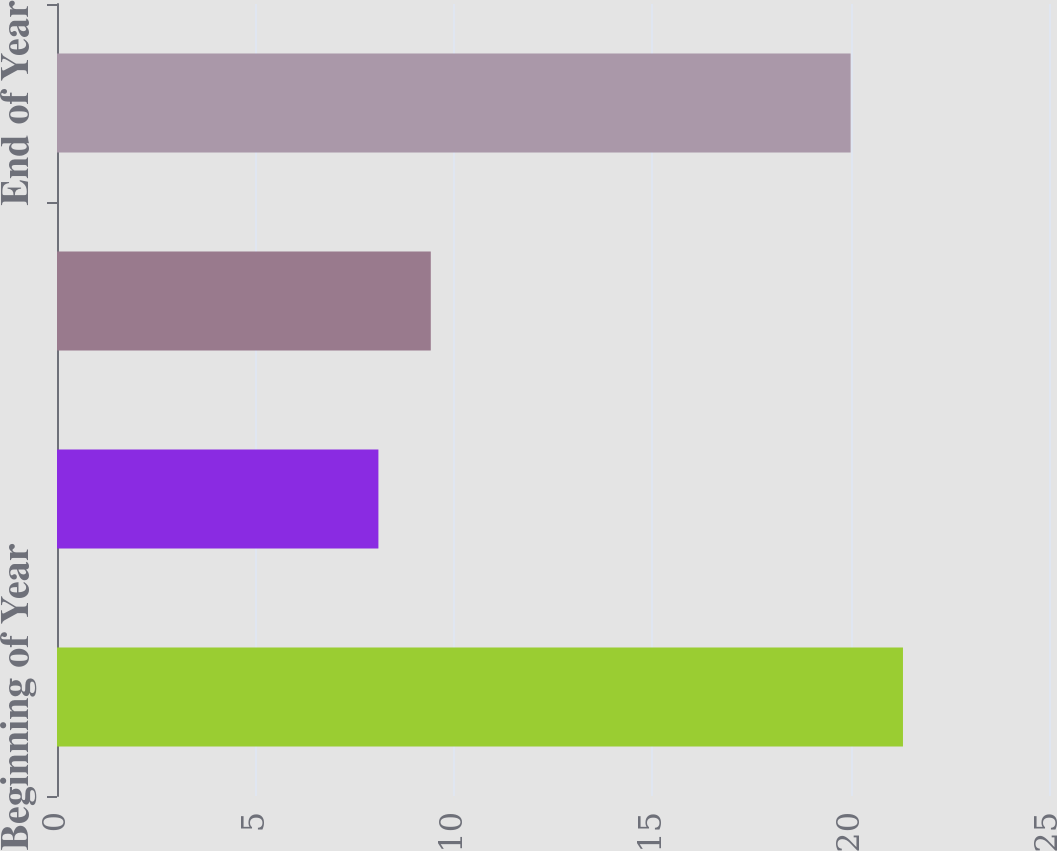<chart> <loc_0><loc_0><loc_500><loc_500><bar_chart><fcel>Beginning of Year<fcel>Capitalization<fcel>Amortization<fcel>End of Year<nl><fcel>21.32<fcel>8.1<fcel>9.42<fcel>20<nl></chart> 